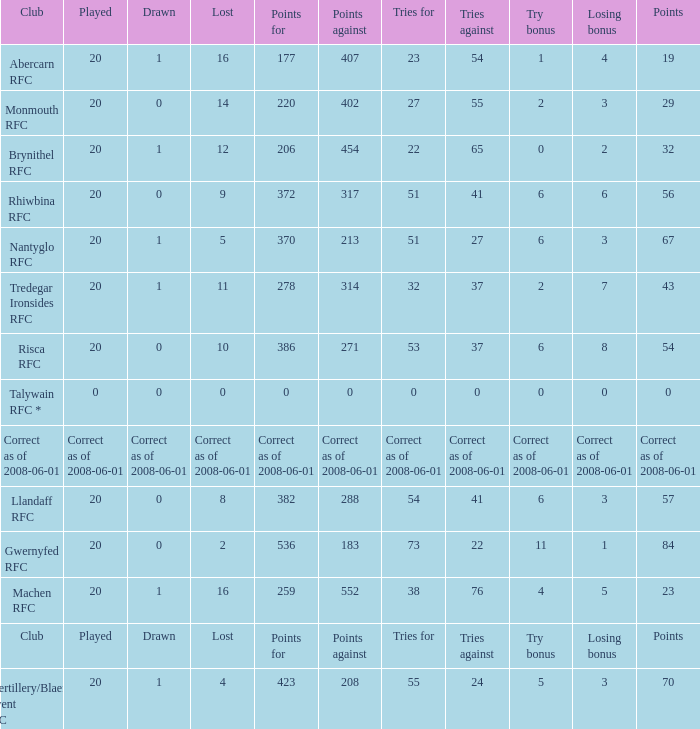What's the try bonus that had 423 points? 5.0. 